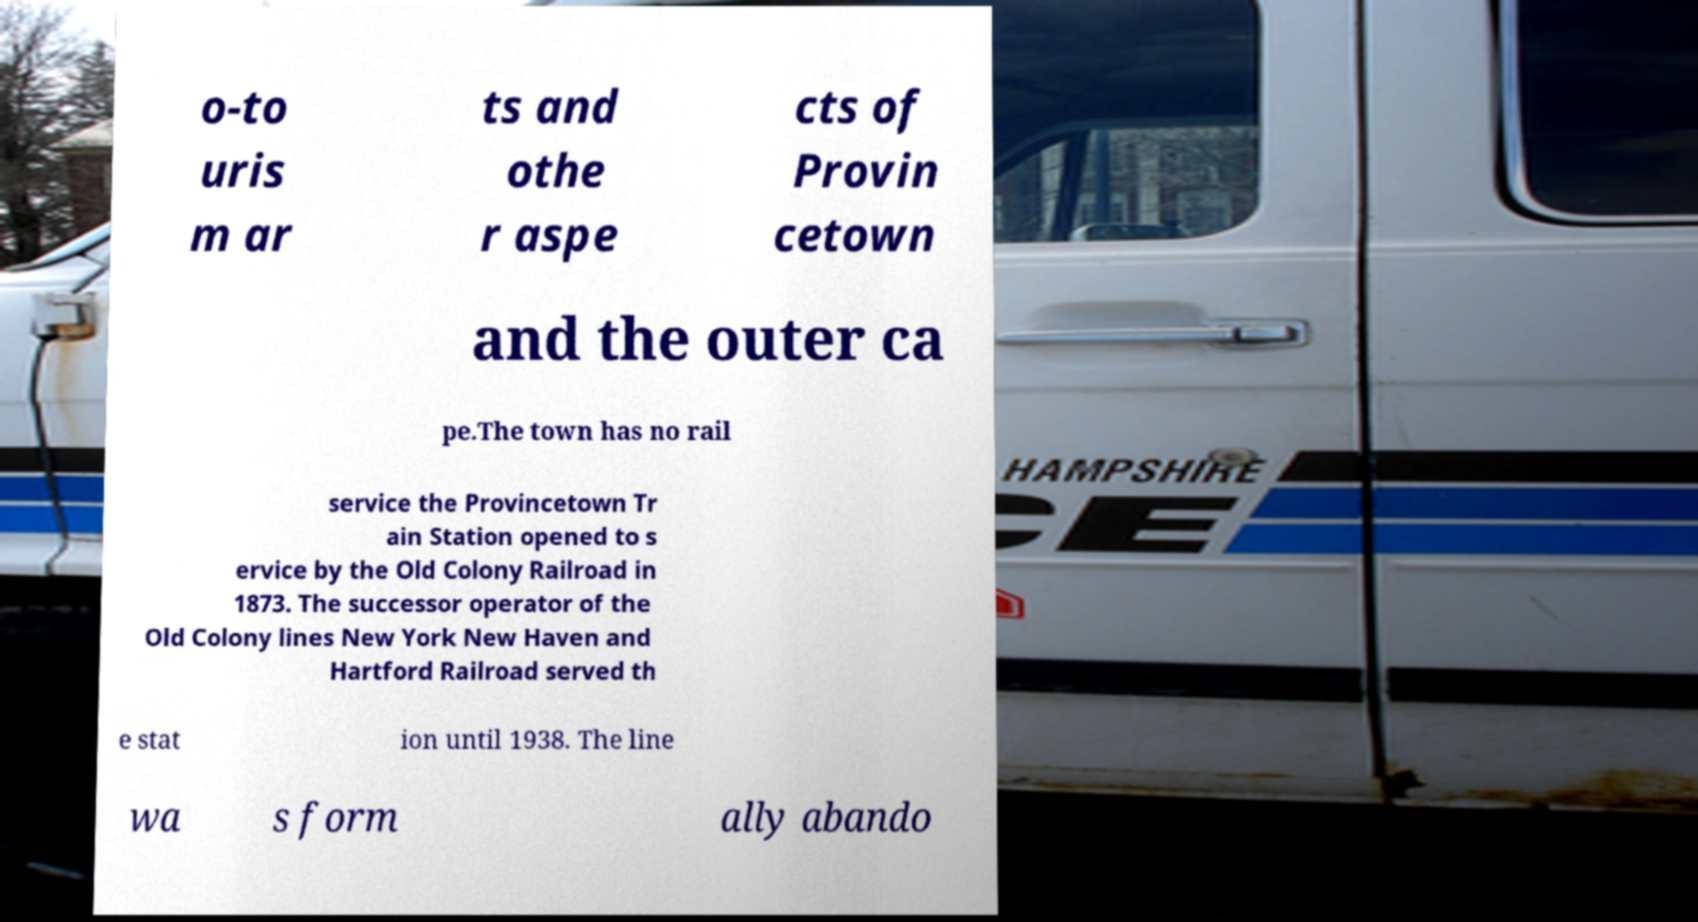Could you assist in decoding the text presented in this image and type it out clearly? o-to uris m ar ts and othe r aspe cts of Provin cetown and the outer ca pe.The town has no rail service the Provincetown Tr ain Station opened to s ervice by the Old Colony Railroad in 1873. The successor operator of the Old Colony lines New York New Haven and Hartford Railroad served th e stat ion until 1938. The line wa s form ally abando 